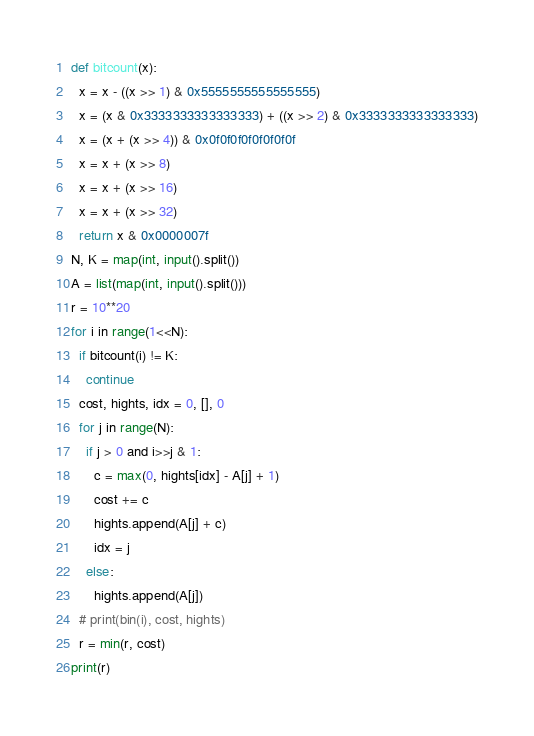Convert code to text. <code><loc_0><loc_0><loc_500><loc_500><_Python_>def bitcount(x):
  x = x - ((x >> 1) & 0x5555555555555555)
  x = (x & 0x3333333333333333) + ((x >> 2) & 0x3333333333333333)
  x = (x + (x >> 4)) & 0x0f0f0f0f0f0f0f0f
  x = x + (x >> 8)
  x = x + (x >> 16)
  x = x + (x >> 32)
  return x & 0x0000007f
N, K = map(int, input().split())
A = list(map(int, input().split()))
r = 10**20
for i in range(1<<N):
  if bitcount(i) != K:
    continue
  cost, hights, idx = 0, [], 0
  for j in range(N):
    if j > 0 and i>>j & 1:
      c = max(0, hights[idx] - A[j] + 1)
      cost += c
      hights.append(A[j] + c)
      idx = j
    else:
      hights.append(A[j])
  # print(bin(i), cost, hights)
  r = min(r, cost)
print(r)</code> 